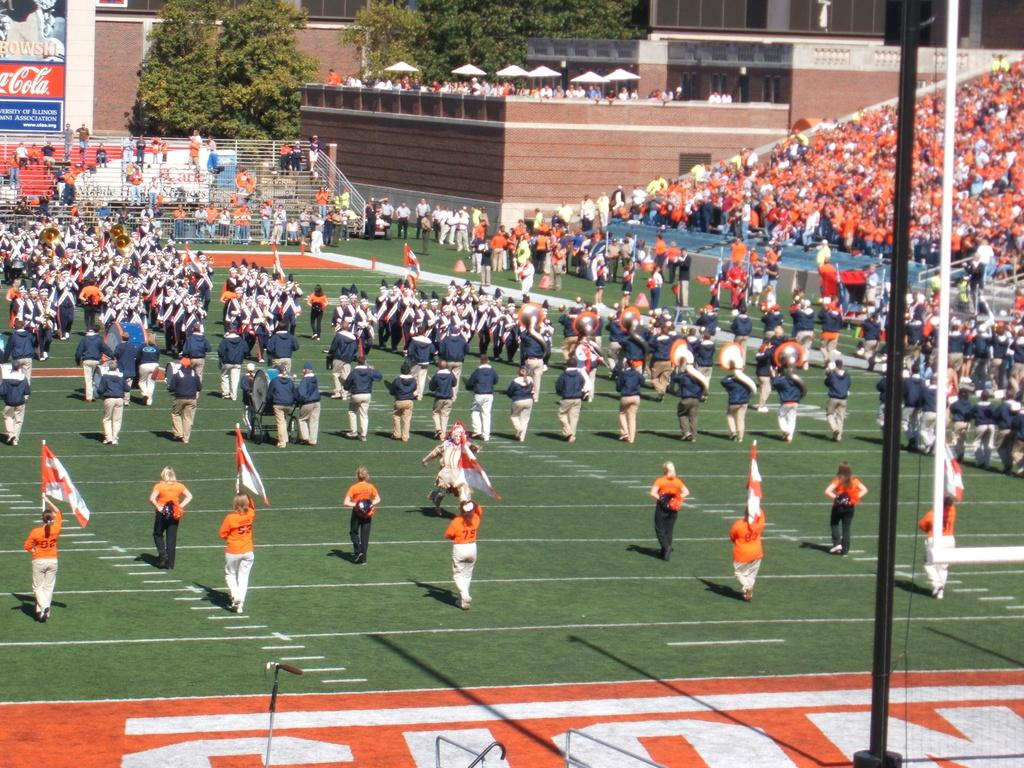How many people are in the image? There are people in the image, but the exact number is not specified. What can be seen besides people in the image? There are flags, a pole, trees, buildings, boards, tents, and railings in the image. What is the location of the flags in the image? The flags are in the image, but their exact location is not specified. What is visible in the background of the image? In the background of the image, there are trees, buildings, and boards. What type of structures are present in the image? There are tents and railings in the image. How many goldfish are swimming in the tents in the image? There are no goldfish present in the image; it features people, flags, a pole, trees, buildings, boards, tents, and railings. 